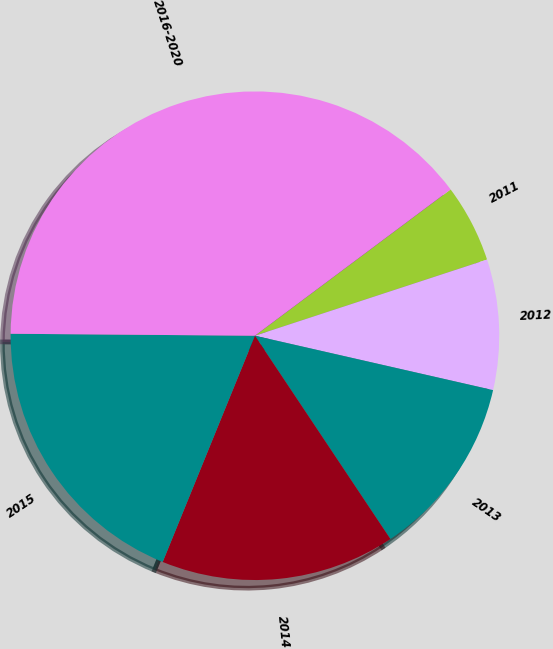<chart> <loc_0><loc_0><loc_500><loc_500><pie_chart><fcel>2011<fcel>2012<fcel>2013<fcel>2014<fcel>2015<fcel>2016-2020<nl><fcel>5.17%<fcel>8.62%<fcel>12.07%<fcel>15.52%<fcel>18.97%<fcel>39.66%<nl></chart> 